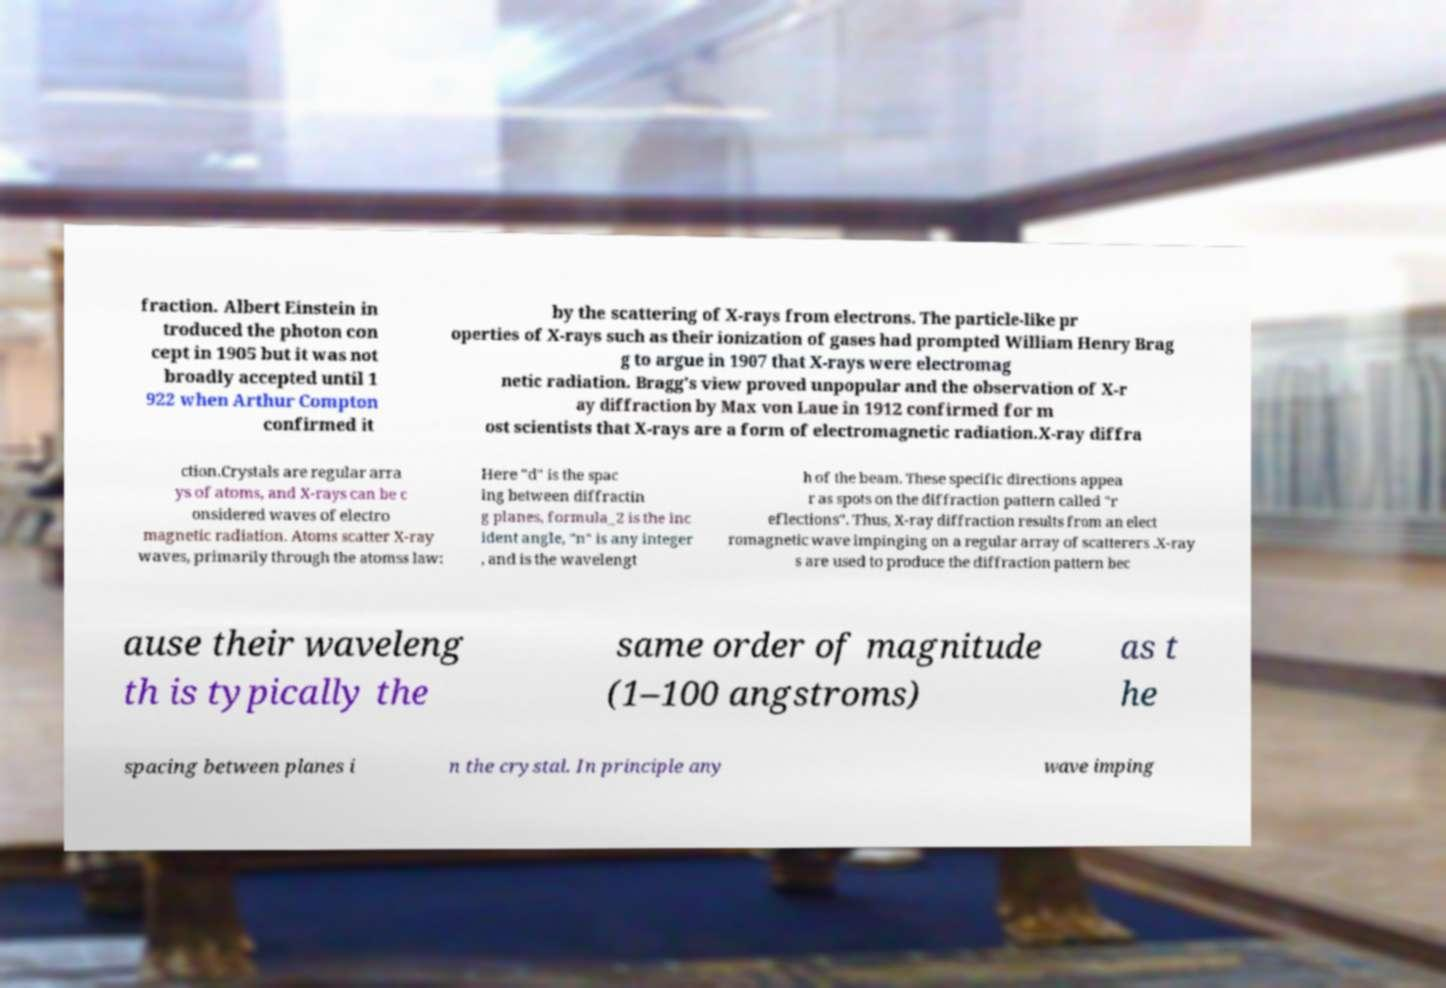Please read and relay the text visible in this image. What does it say? fraction. Albert Einstein in troduced the photon con cept in 1905 but it was not broadly accepted until 1 922 when Arthur Compton confirmed it by the scattering of X-rays from electrons. The particle-like pr operties of X-rays such as their ionization of gases had prompted William Henry Brag g to argue in 1907 that X-rays were electromag netic radiation. Bragg's view proved unpopular and the observation of X-r ay diffraction by Max von Laue in 1912 confirmed for m ost scientists that X-rays are a form of electromagnetic radiation.X-ray diffra ction.Crystals are regular arra ys of atoms, and X-rays can be c onsidered waves of electro magnetic radiation. Atoms scatter X-ray waves, primarily through the atomss law: Here "d" is the spac ing between diffractin g planes, formula_2 is the inc ident angle, "n" is any integer , and is the wavelengt h of the beam. These specific directions appea r as spots on the diffraction pattern called "r eflections". Thus, X-ray diffraction results from an elect romagnetic wave impinging on a regular array of scatterers .X-ray s are used to produce the diffraction pattern bec ause their waveleng th is typically the same order of magnitude (1–100 angstroms) as t he spacing between planes i n the crystal. In principle any wave imping 